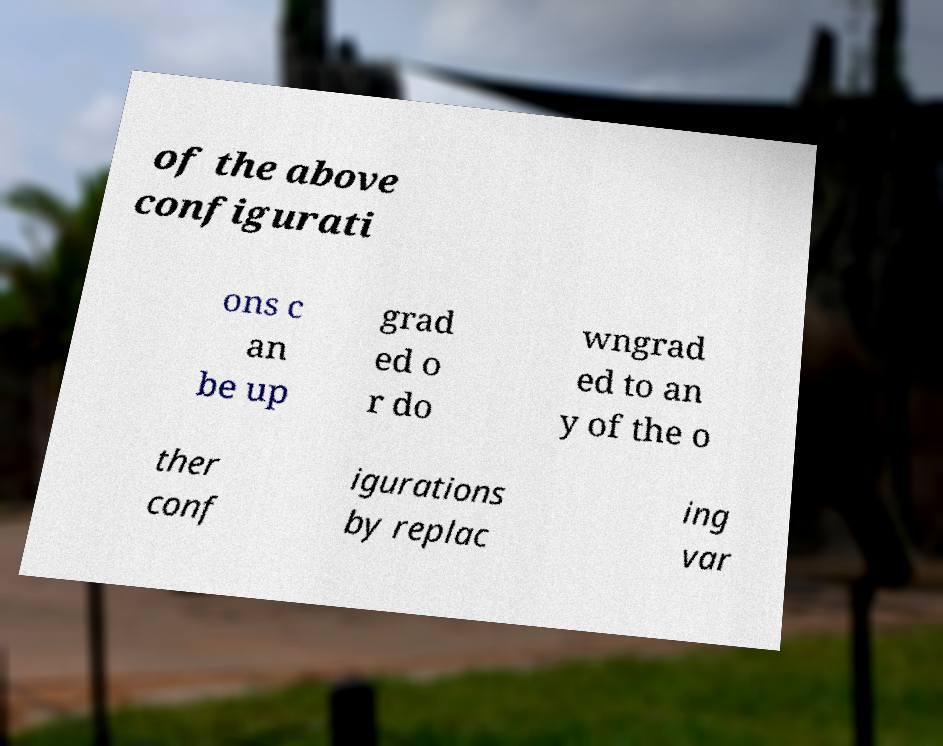Can you accurately transcribe the text from the provided image for me? of the above configurati ons c an be up grad ed o r do wngrad ed to an y of the o ther conf igurations by replac ing var 